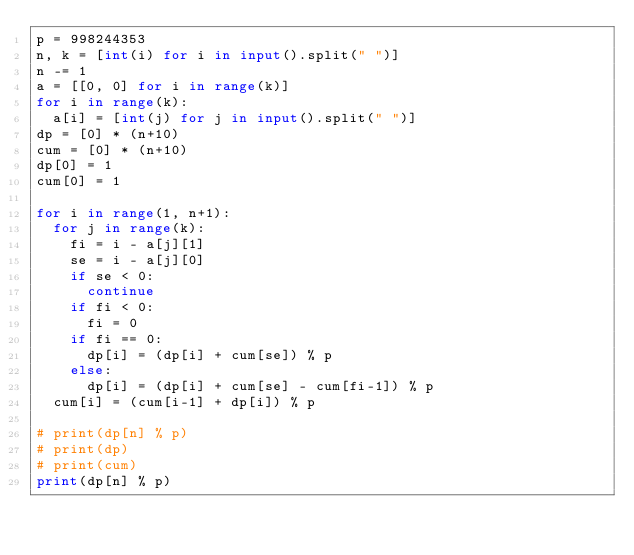Convert code to text. <code><loc_0><loc_0><loc_500><loc_500><_Python_>p = 998244353
n, k = [int(i) for i in input().split(" ")]
n -= 1
a = [[0, 0] for i in range(k)]
for i in range(k):
  a[i] = [int(j) for j in input().split(" ")]
dp = [0] * (n+10)
cum = [0] * (n+10)
dp[0] = 1
cum[0] = 1

for i in range(1, n+1):
  for j in range(k):
    fi = i - a[j][1]
    se = i - a[j][0]
    if se < 0:
      continue
    if fi < 0:
      fi = 0
    if fi == 0:
      dp[i] = (dp[i] + cum[se]) % p
    else:
      dp[i] = (dp[i] + cum[se] - cum[fi-1]) % p
  cum[i] = (cum[i-1] + dp[i]) % p

# print(dp[n] % p)
# print(dp)
# print(cum)
print(dp[n] % p)</code> 